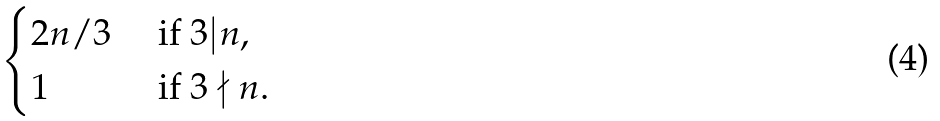<formula> <loc_0><loc_0><loc_500><loc_500>\begin{cases} 2 n / 3 & \text { if } 3 | n , \\ 1 & \text { if } 3 \nmid n . \end{cases}</formula> 